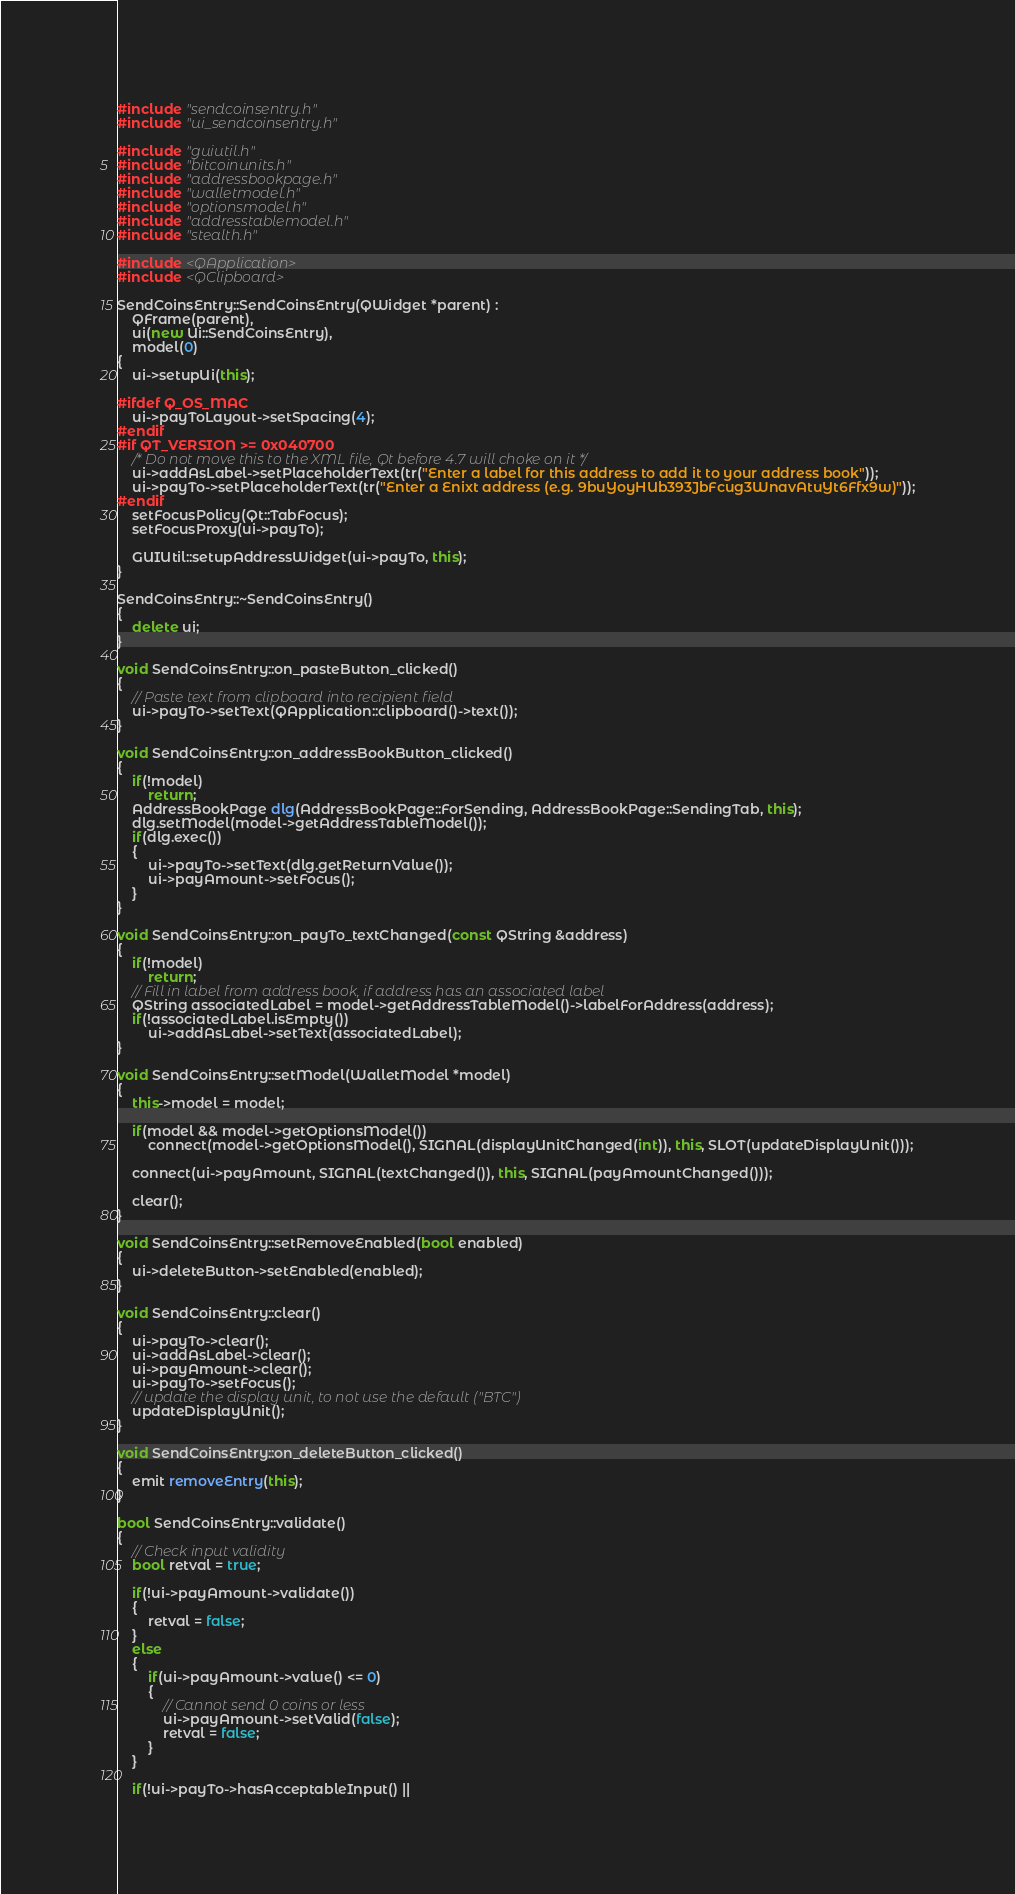<code> <loc_0><loc_0><loc_500><loc_500><_C++_>#include "sendcoinsentry.h"
#include "ui_sendcoinsentry.h"

#include "guiutil.h"
#include "bitcoinunits.h"
#include "addressbookpage.h"
#include "walletmodel.h"
#include "optionsmodel.h"
#include "addresstablemodel.h"
#include "stealth.h"

#include <QApplication>
#include <QClipboard>

SendCoinsEntry::SendCoinsEntry(QWidget *parent) :
    QFrame(parent),
    ui(new Ui::SendCoinsEntry),
    model(0)
{
    ui->setupUi(this);

#ifdef Q_OS_MAC
    ui->payToLayout->setSpacing(4);
#endif
#if QT_VERSION >= 0x040700
    /* Do not move this to the XML file, Qt before 4.7 will choke on it */
    ui->addAsLabel->setPlaceholderText(tr("Enter a label for this address to add it to your address book"));
    ui->payTo->setPlaceholderText(tr("Enter a Enixt address (e.g. 9buYoyHUb393JbFcug3WnavAtuYt6Ffx9w)"));
#endif
    setFocusPolicy(Qt::TabFocus);
    setFocusProxy(ui->payTo);

    GUIUtil::setupAddressWidget(ui->payTo, this);
}

SendCoinsEntry::~SendCoinsEntry()
{
    delete ui;
}

void SendCoinsEntry::on_pasteButton_clicked()
{
    // Paste text from clipboard into recipient field
    ui->payTo->setText(QApplication::clipboard()->text());
}

void SendCoinsEntry::on_addressBookButton_clicked()
{
    if(!model)
        return;
    AddressBookPage dlg(AddressBookPage::ForSending, AddressBookPage::SendingTab, this);
    dlg.setModel(model->getAddressTableModel());
    if(dlg.exec())
    {
        ui->payTo->setText(dlg.getReturnValue());
        ui->payAmount->setFocus();
    }
}

void SendCoinsEntry::on_payTo_textChanged(const QString &address)
{
    if(!model)
        return;
    // Fill in label from address book, if address has an associated label
    QString associatedLabel = model->getAddressTableModel()->labelForAddress(address);
    if(!associatedLabel.isEmpty())
        ui->addAsLabel->setText(associatedLabel);
}

void SendCoinsEntry::setModel(WalletModel *model)
{
    this->model = model;

    if(model && model->getOptionsModel())
        connect(model->getOptionsModel(), SIGNAL(displayUnitChanged(int)), this, SLOT(updateDisplayUnit()));

    connect(ui->payAmount, SIGNAL(textChanged()), this, SIGNAL(payAmountChanged()));

    clear();
}

void SendCoinsEntry::setRemoveEnabled(bool enabled)
{
    ui->deleteButton->setEnabled(enabled);
}

void SendCoinsEntry::clear()
{
    ui->payTo->clear();
    ui->addAsLabel->clear();
    ui->payAmount->clear();
    ui->payTo->setFocus();
    // update the display unit, to not use the default ("BTC")
    updateDisplayUnit();
}

void SendCoinsEntry::on_deleteButton_clicked()
{
    emit removeEntry(this);
}

bool SendCoinsEntry::validate()
{
    // Check input validity
    bool retval = true;

    if(!ui->payAmount->validate())
    {
        retval = false;
    }
    else
    {
        if(ui->payAmount->value() <= 0)
        {
            // Cannot send 0 coins or less
            ui->payAmount->setValid(false);
            retval = false;
        }
    }

    if(!ui->payTo->hasAcceptableInput() ||</code> 